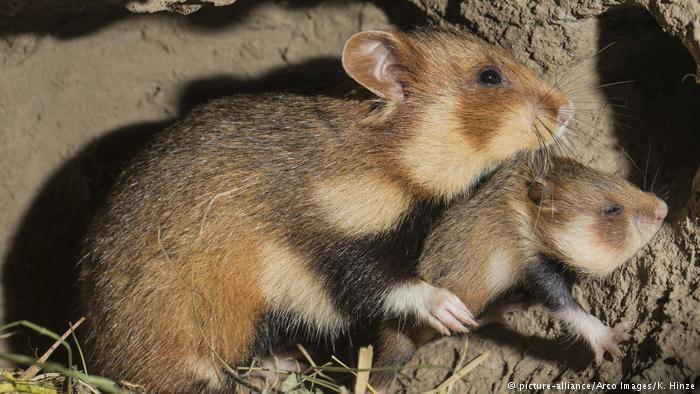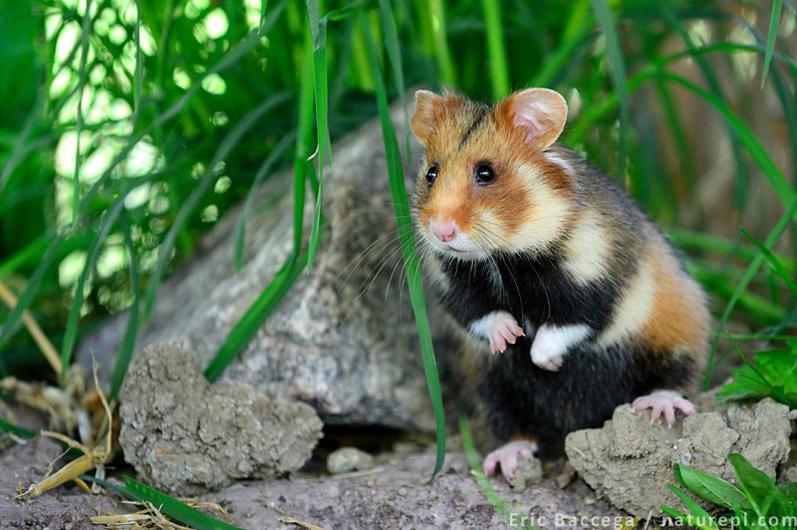The first image is the image on the left, the second image is the image on the right. For the images shown, is this caption "in one image a hamster with a black stomach is standing in grass and looking to the left" true? Answer yes or no. Yes. 